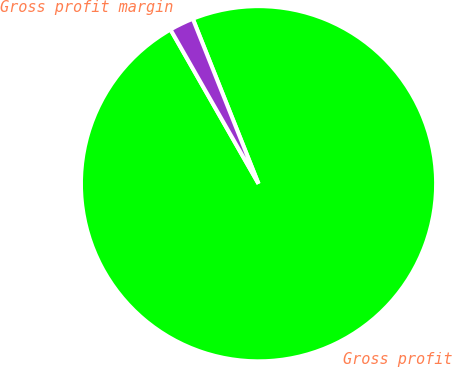<chart> <loc_0><loc_0><loc_500><loc_500><pie_chart><fcel>Gross profit<fcel>Gross profit margin<nl><fcel>97.78%<fcel>2.22%<nl></chart> 